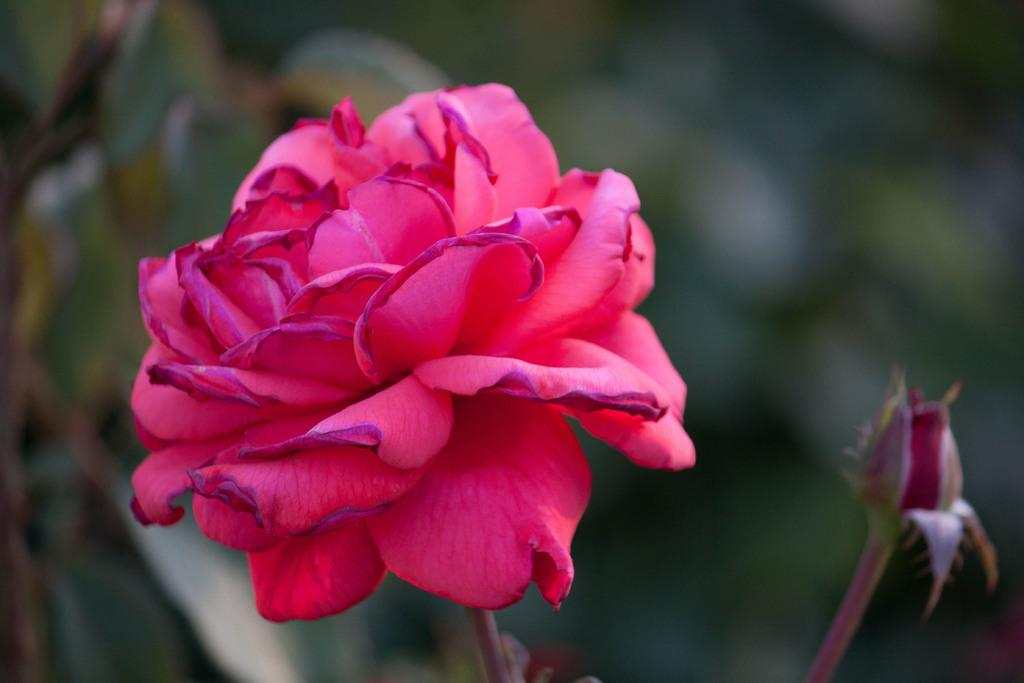Where was the image taken? The image was taken outdoors. Can you describe the background of the image? The background of the image is slightly blurred. What is the main subject of the image? There is a red rose in the middle of the image. Are there any other flowers visible in the image? Yes, there is a rose bud in the image. How do the giants feel about the red rose in the image? There are no giants present in the image, so it is not possible to determine their feelings about the red rose. 